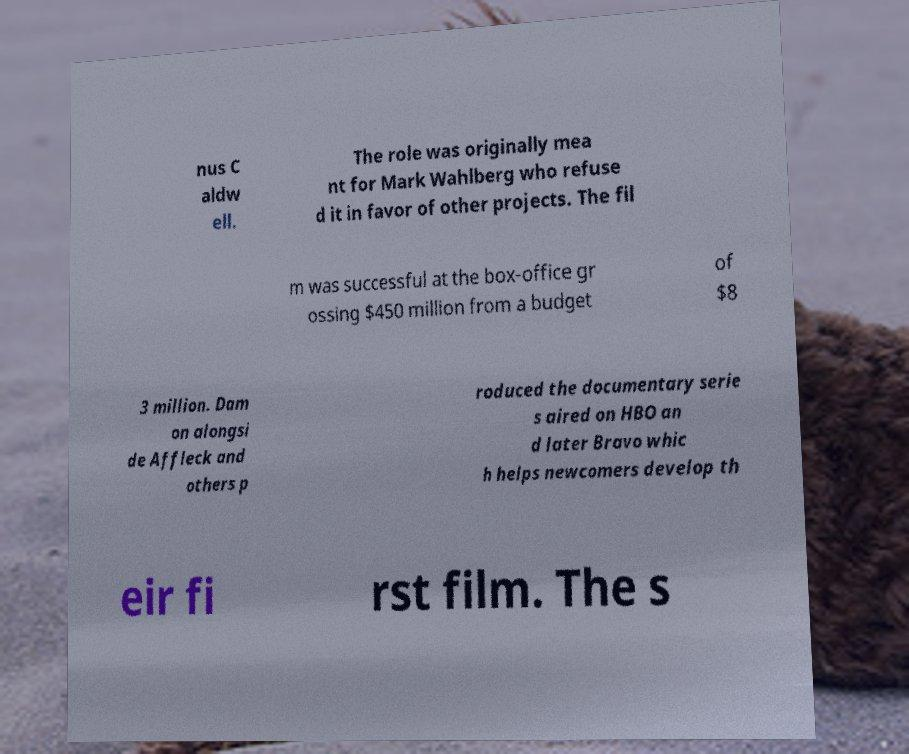What messages or text are displayed in this image? I need them in a readable, typed format. nus C aldw ell. The role was originally mea nt for Mark Wahlberg who refuse d it in favor of other projects. The fil m was successful at the box-office gr ossing $450 million from a budget of $8 3 million. Dam on alongsi de Affleck and others p roduced the documentary serie s aired on HBO an d later Bravo whic h helps newcomers develop th eir fi rst film. The s 